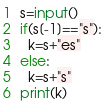<code> <loc_0><loc_0><loc_500><loc_500><_Python_>s=input()
if(s[-1]=="s"):
  k=s+"es"
else:
  k=s+"s"
print(k)</code> 